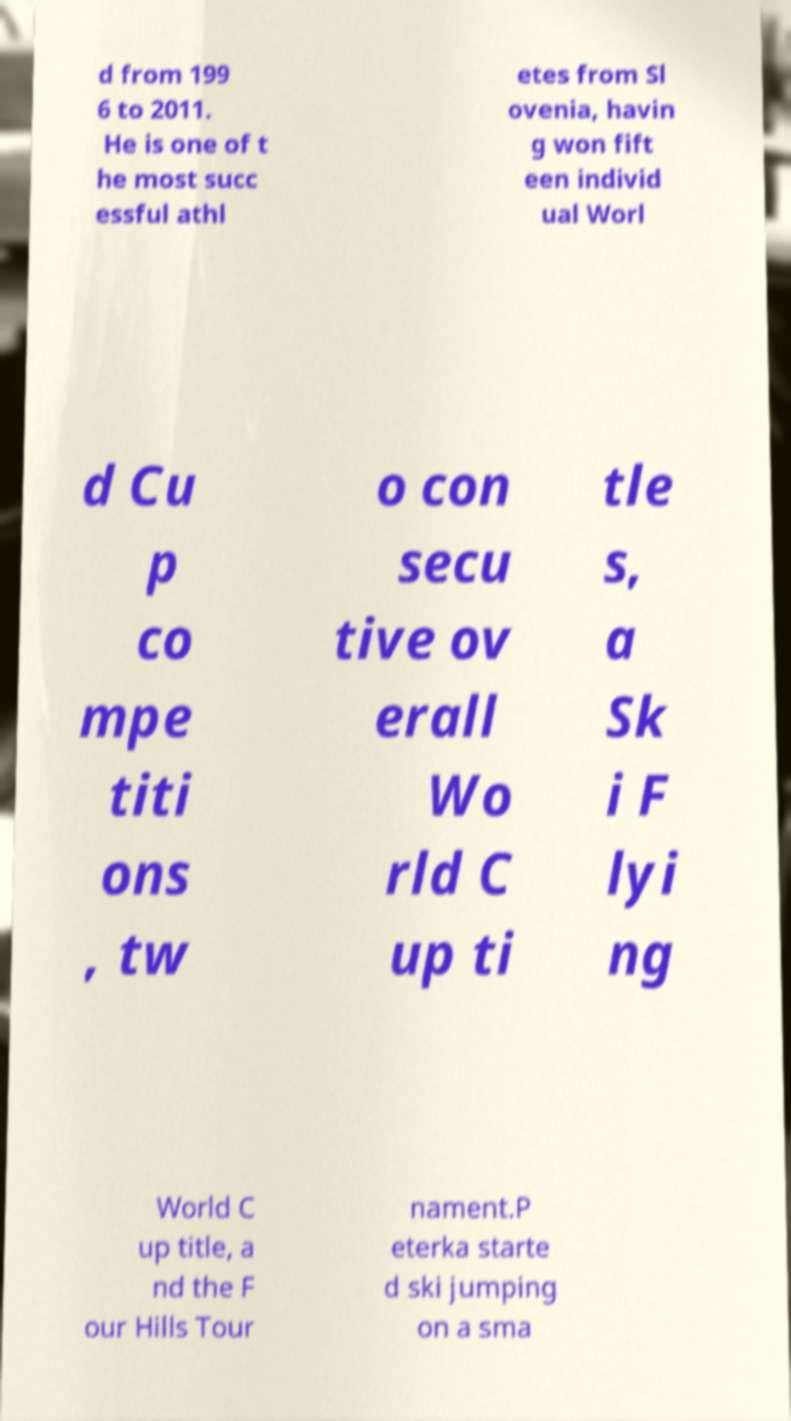What messages or text are displayed in this image? I need them in a readable, typed format. d from 199 6 to 2011. He is one of t he most succ essful athl etes from Sl ovenia, havin g won fift een individ ual Worl d Cu p co mpe titi ons , tw o con secu tive ov erall Wo rld C up ti tle s, a Sk i F lyi ng World C up title, a nd the F our Hills Tour nament.P eterka starte d ski jumping on a sma 